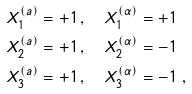Convert formula to latex. <formula><loc_0><loc_0><loc_500><loc_500>& X _ { 1 } ^ { ( a ) } = + 1 \, , \quad X _ { 1 } ^ { ( \alpha ) } = + 1 \\ & X _ { 2 } ^ { ( a ) } = + 1 \, , \quad X _ { 2 } ^ { ( \alpha ) } = - 1 \\ & X _ { 3 } ^ { ( a ) } = + 1 \, , \quad X _ { 3 } ^ { ( \alpha ) } = - 1 \ , \\</formula> 